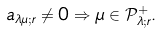Convert formula to latex. <formula><loc_0><loc_0><loc_500><loc_500>a _ { \lambda \mu ; r } \neq 0 \Rightarrow \mu \in \mathcal { P } ^ { + } _ { \lambda ; r } .</formula> 